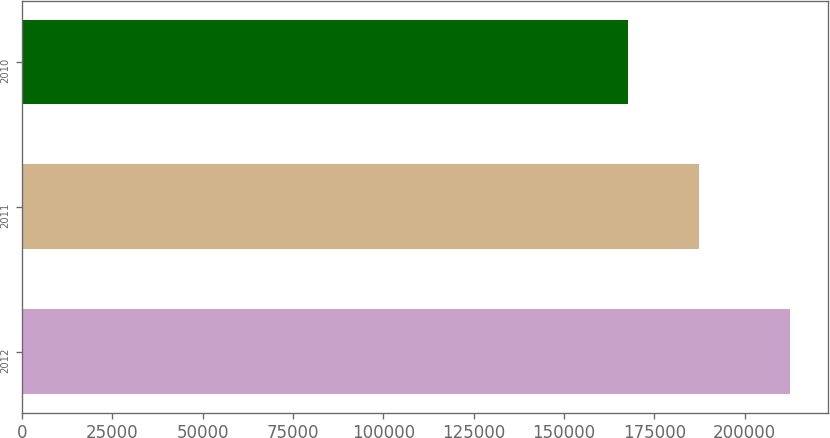<chart> <loc_0><loc_0><loc_500><loc_500><bar_chart><fcel>2012<fcel>2011<fcel>2010<nl><fcel>212499<fcel>187457<fcel>167633<nl></chart> 